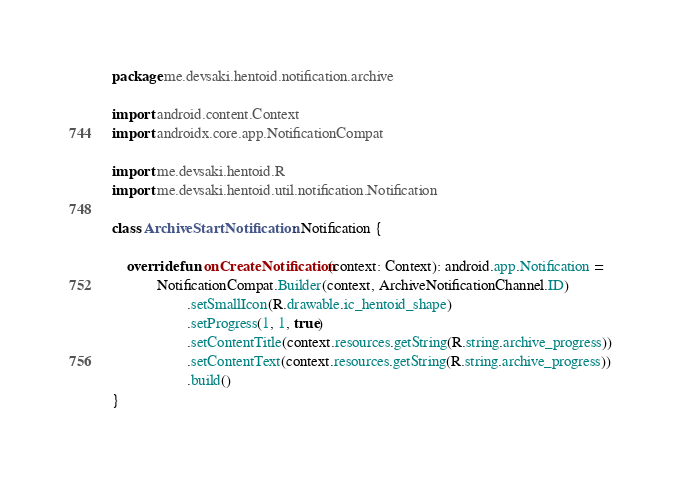<code> <loc_0><loc_0><loc_500><loc_500><_Kotlin_>package me.devsaki.hentoid.notification.archive

import android.content.Context
import androidx.core.app.NotificationCompat

import me.devsaki.hentoid.R
import me.devsaki.hentoid.util.notification.Notification

class ArchiveStartNotification : Notification {

    override fun onCreateNotification(context: Context): android.app.Notification =
            NotificationCompat.Builder(context, ArchiveNotificationChannel.ID)
                    .setSmallIcon(R.drawable.ic_hentoid_shape)
                    .setProgress(1, 1, true)
                    .setContentTitle(context.resources.getString(R.string.archive_progress))
                    .setContentText(context.resources.getString(R.string.archive_progress))
                    .build()
}
</code> 